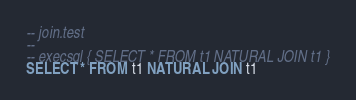Convert code to text. <code><loc_0><loc_0><loc_500><loc_500><_SQL_>-- join.test
-- 
-- execsql { SELECT * FROM t1 NATURAL JOIN t1 }
SELECT * FROM t1 NATURAL JOIN t1</code> 